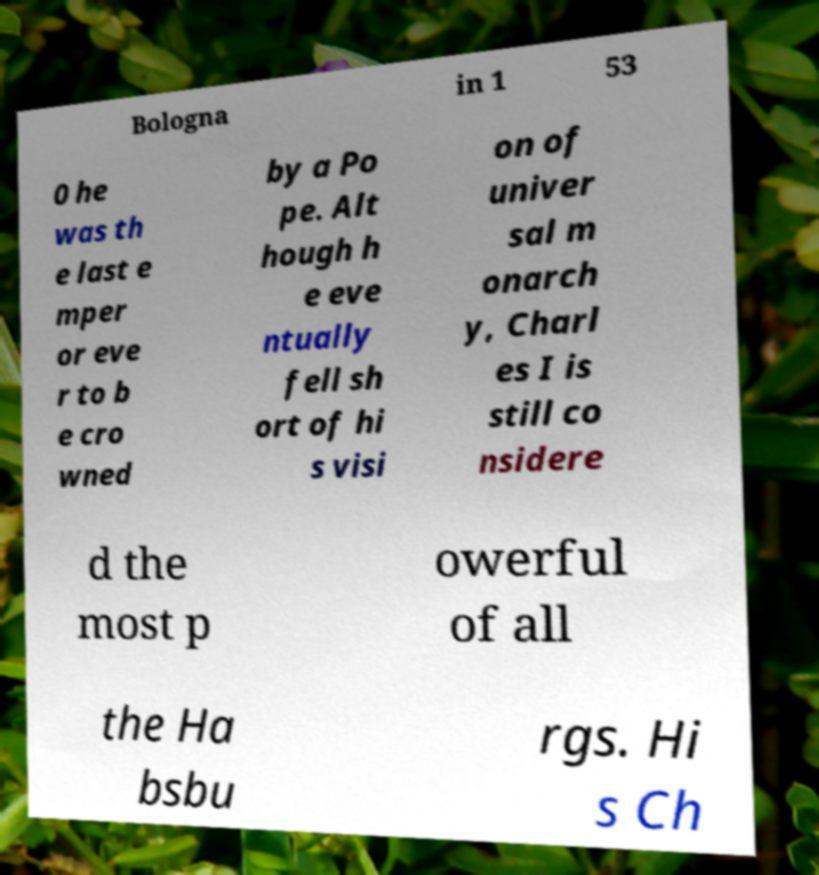Could you extract and type out the text from this image? Bologna in 1 53 0 he was th e last e mper or eve r to b e cro wned by a Po pe. Alt hough h e eve ntually fell sh ort of hi s visi on of univer sal m onarch y, Charl es I is still co nsidere d the most p owerful of all the Ha bsbu rgs. Hi s Ch 